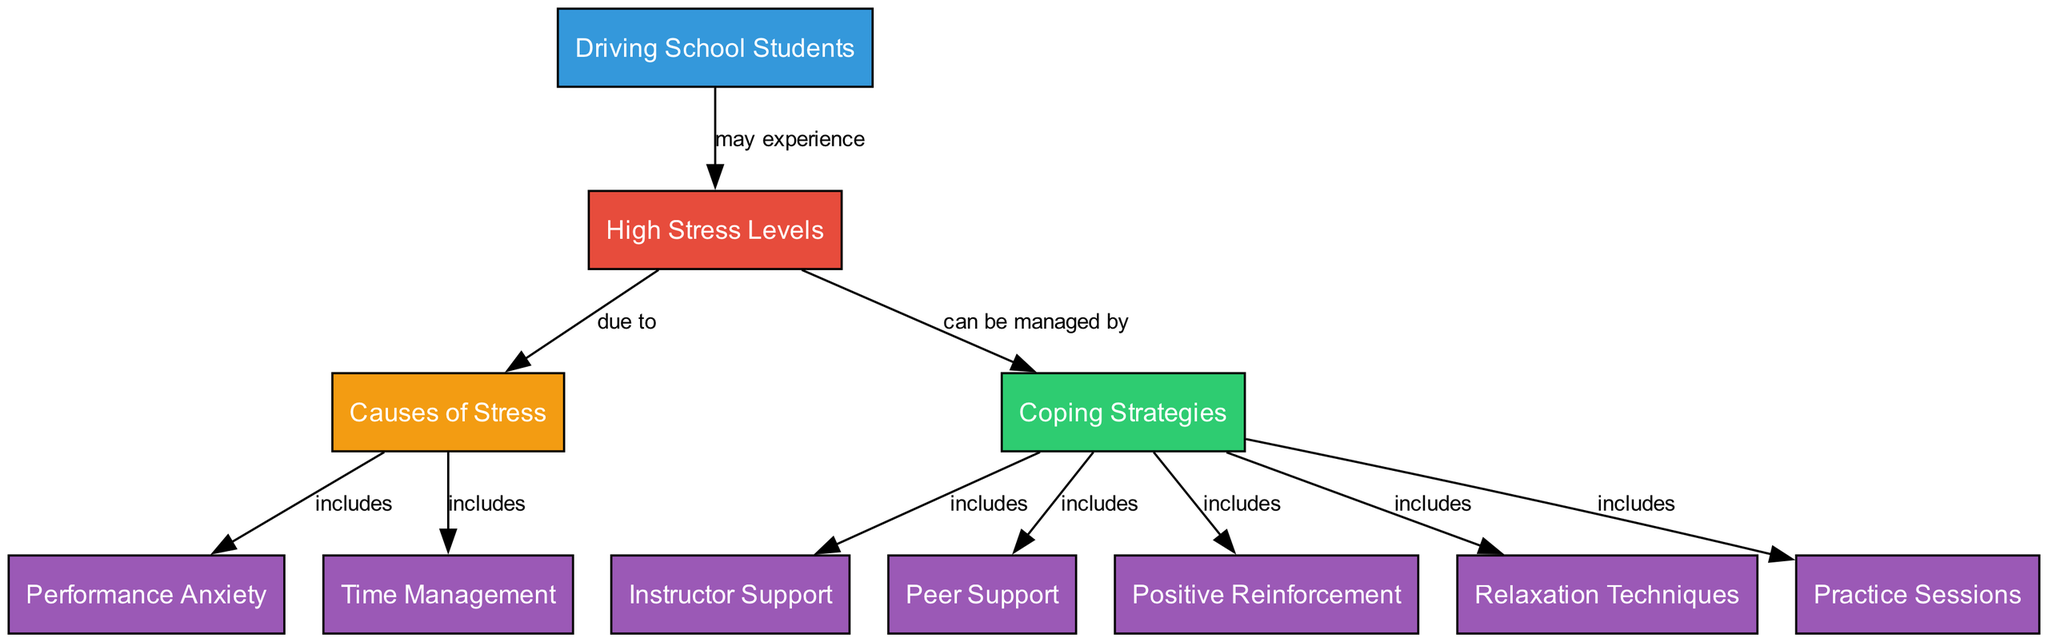What are the main categories related to driving school students? In the diagram, there are three main categories related to driving school students: High Stress Levels, Causes of Stress, and Coping Strategies. Each of these categories has several connected nodes.
Answer: High Stress Levels, Causes of Stress, Coping Strategies How many nodes are there in the diagram? The total number of nodes is the count of all distinct entities represented, which includes Driving School Students, High Stress Levels, Causes of Stress, Coping Strategies, and several others, totaling eleven nodes.
Answer: 11 What can help manage high stress levels? The diagram shows that high stress levels can be managed by Coping Strategies, which includes various methods such as Instructor Support, Peer Support, Positive Reinforcement, Relaxation Techniques, and Practice Sessions.
Answer: Coping Strategies What relationship exists between causes of stress and performance anxiety? From the diagram, it can be seen that Causes of Stress includes Performance Anxiety. This indicates that performance anxiety is a specific factor contributing to stress levels.
Answer: includes How many coping strategies are included in the diagram? The diagram lists five coping strategies, which are Instructor Support, Peer Support, Positive Reinforcement, Relaxation Techniques, and Practice Sessions. Thus, the number of coping strategies is five as represented in the diagram.
Answer: 5 What is a cause of stress related to time management? The diagram specifies that Causes of Stress includes Time Management. This indicates that inefficient time management may lead to elevated stress levels among driving school students.
Answer: Time Management What type of support is mentioned as a coping strategy in the diagram? The diagram includes two types of support under Coping Strategies: Instructor Support and Peer Support. These forms of support are intended to help students cope with stress effectively.
Answer: Instructor Support, Peer Support What do high stress levels lead to in driving school students? According to the diagram, high stress levels may lead to various Causes of Stress, which include Performance Anxiety and Time Management issues. Thus, this highlights a connection between high stress levels and specific stressors.
Answer: Causes of Stress 